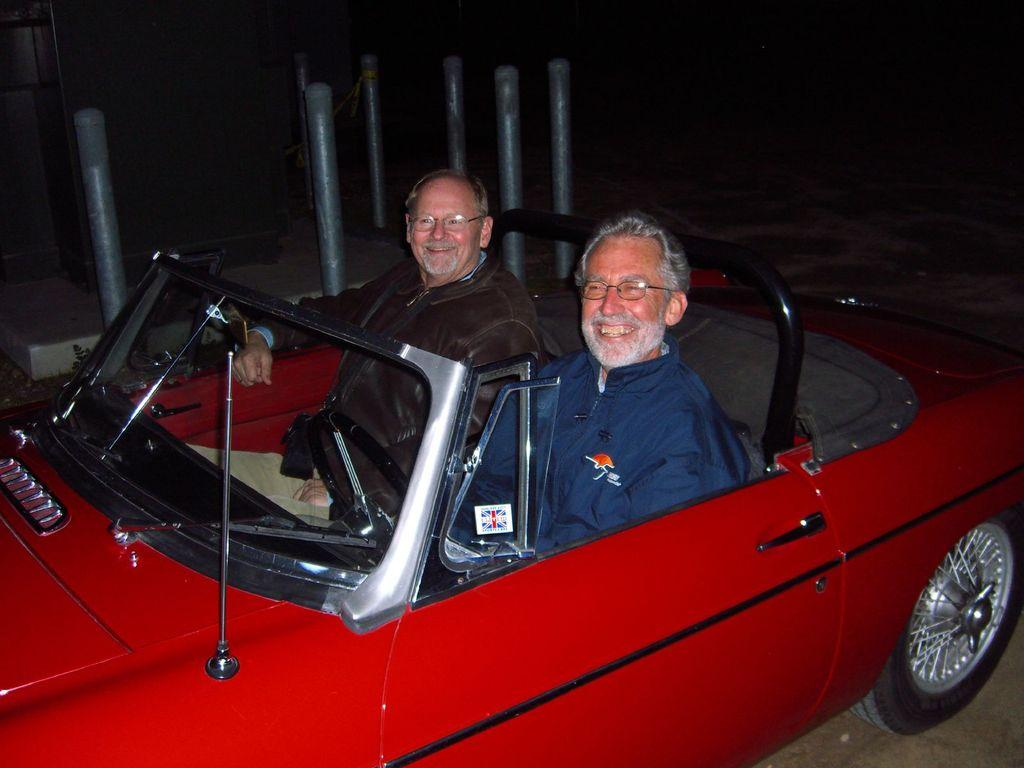What color is the car in the image? There is a red color car in the image. Who is inside the car? There are two men sitting in the car. What is the facial expression of the men in the image? The men are smiling. What type of creature is sitting between the two men in the car? There is no creature present in the image; only the two men are visible. What decision did the men make before entering the car? The provided facts do not mention any decisions made by the men, so it cannot be determined from the image. 